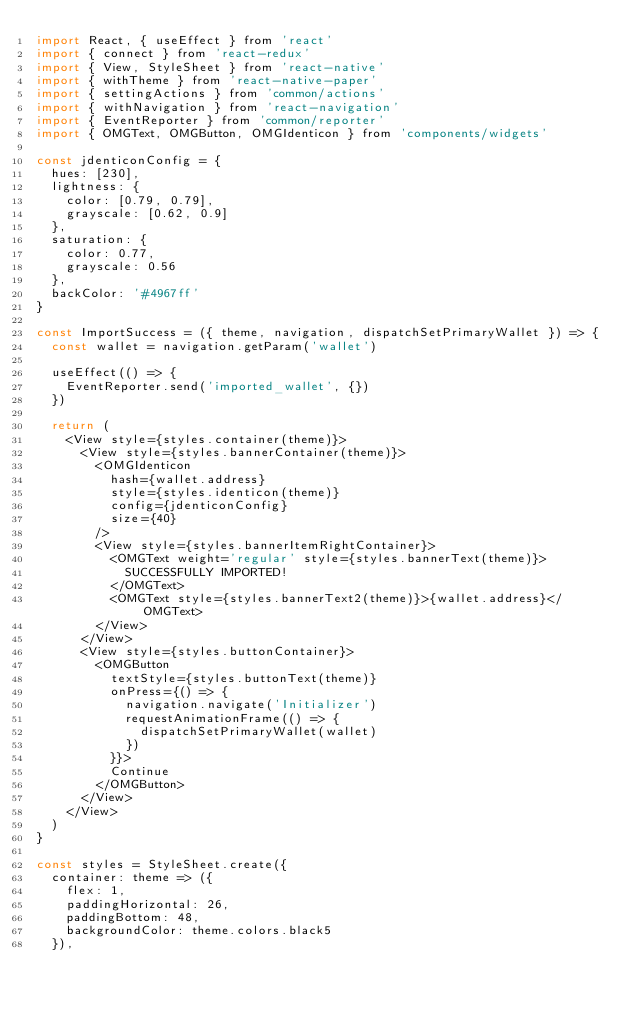Convert code to text. <code><loc_0><loc_0><loc_500><loc_500><_JavaScript_>import React, { useEffect } from 'react'
import { connect } from 'react-redux'
import { View, StyleSheet } from 'react-native'
import { withTheme } from 'react-native-paper'
import { settingActions } from 'common/actions'
import { withNavigation } from 'react-navigation'
import { EventReporter } from 'common/reporter'
import { OMGText, OMGButton, OMGIdenticon } from 'components/widgets'

const jdenticonConfig = {
  hues: [230],
  lightness: {
    color: [0.79, 0.79],
    grayscale: [0.62, 0.9]
  },
  saturation: {
    color: 0.77,
    grayscale: 0.56
  },
  backColor: '#4967ff'
}

const ImportSuccess = ({ theme, navigation, dispatchSetPrimaryWallet }) => {
  const wallet = navigation.getParam('wallet')

  useEffect(() => {
    EventReporter.send('imported_wallet', {})
  })

  return (
    <View style={styles.container(theme)}>
      <View style={styles.bannerContainer(theme)}>
        <OMGIdenticon
          hash={wallet.address}
          style={styles.identicon(theme)}
          config={jdenticonConfig}
          size={40}
        />
        <View style={styles.bannerItemRightContainer}>
          <OMGText weight='regular' style={styles.bannerText(theme)}>
            SUCCESSFULLY IMPORTED!
          </OMGText>
          <OMGText style={styles.bannerText2(theme)}>{wallet.address}</OMGText>
        </View>
      </View>
      <View style={styles.buttonContainer}>
        <OMGButton
          textStyle={styles.buttonText(theme)}
          onPress={() => {
            navigation.navigate('Initializer')
            requestAnimationFrame(() => {
              dispatchSetPrimaryWallet(wallet)
            })
          }}>
          Continue
        </OMGButton>
      </View>
    </View>
  )
}

const styles = StyleSheet.create({
  container: theme => ({
    flex: 1,
    paddingHorizontal: 26,
    paddingBottom: 48,
    backgroundColor: theme.colors.black5
  }),</code> 